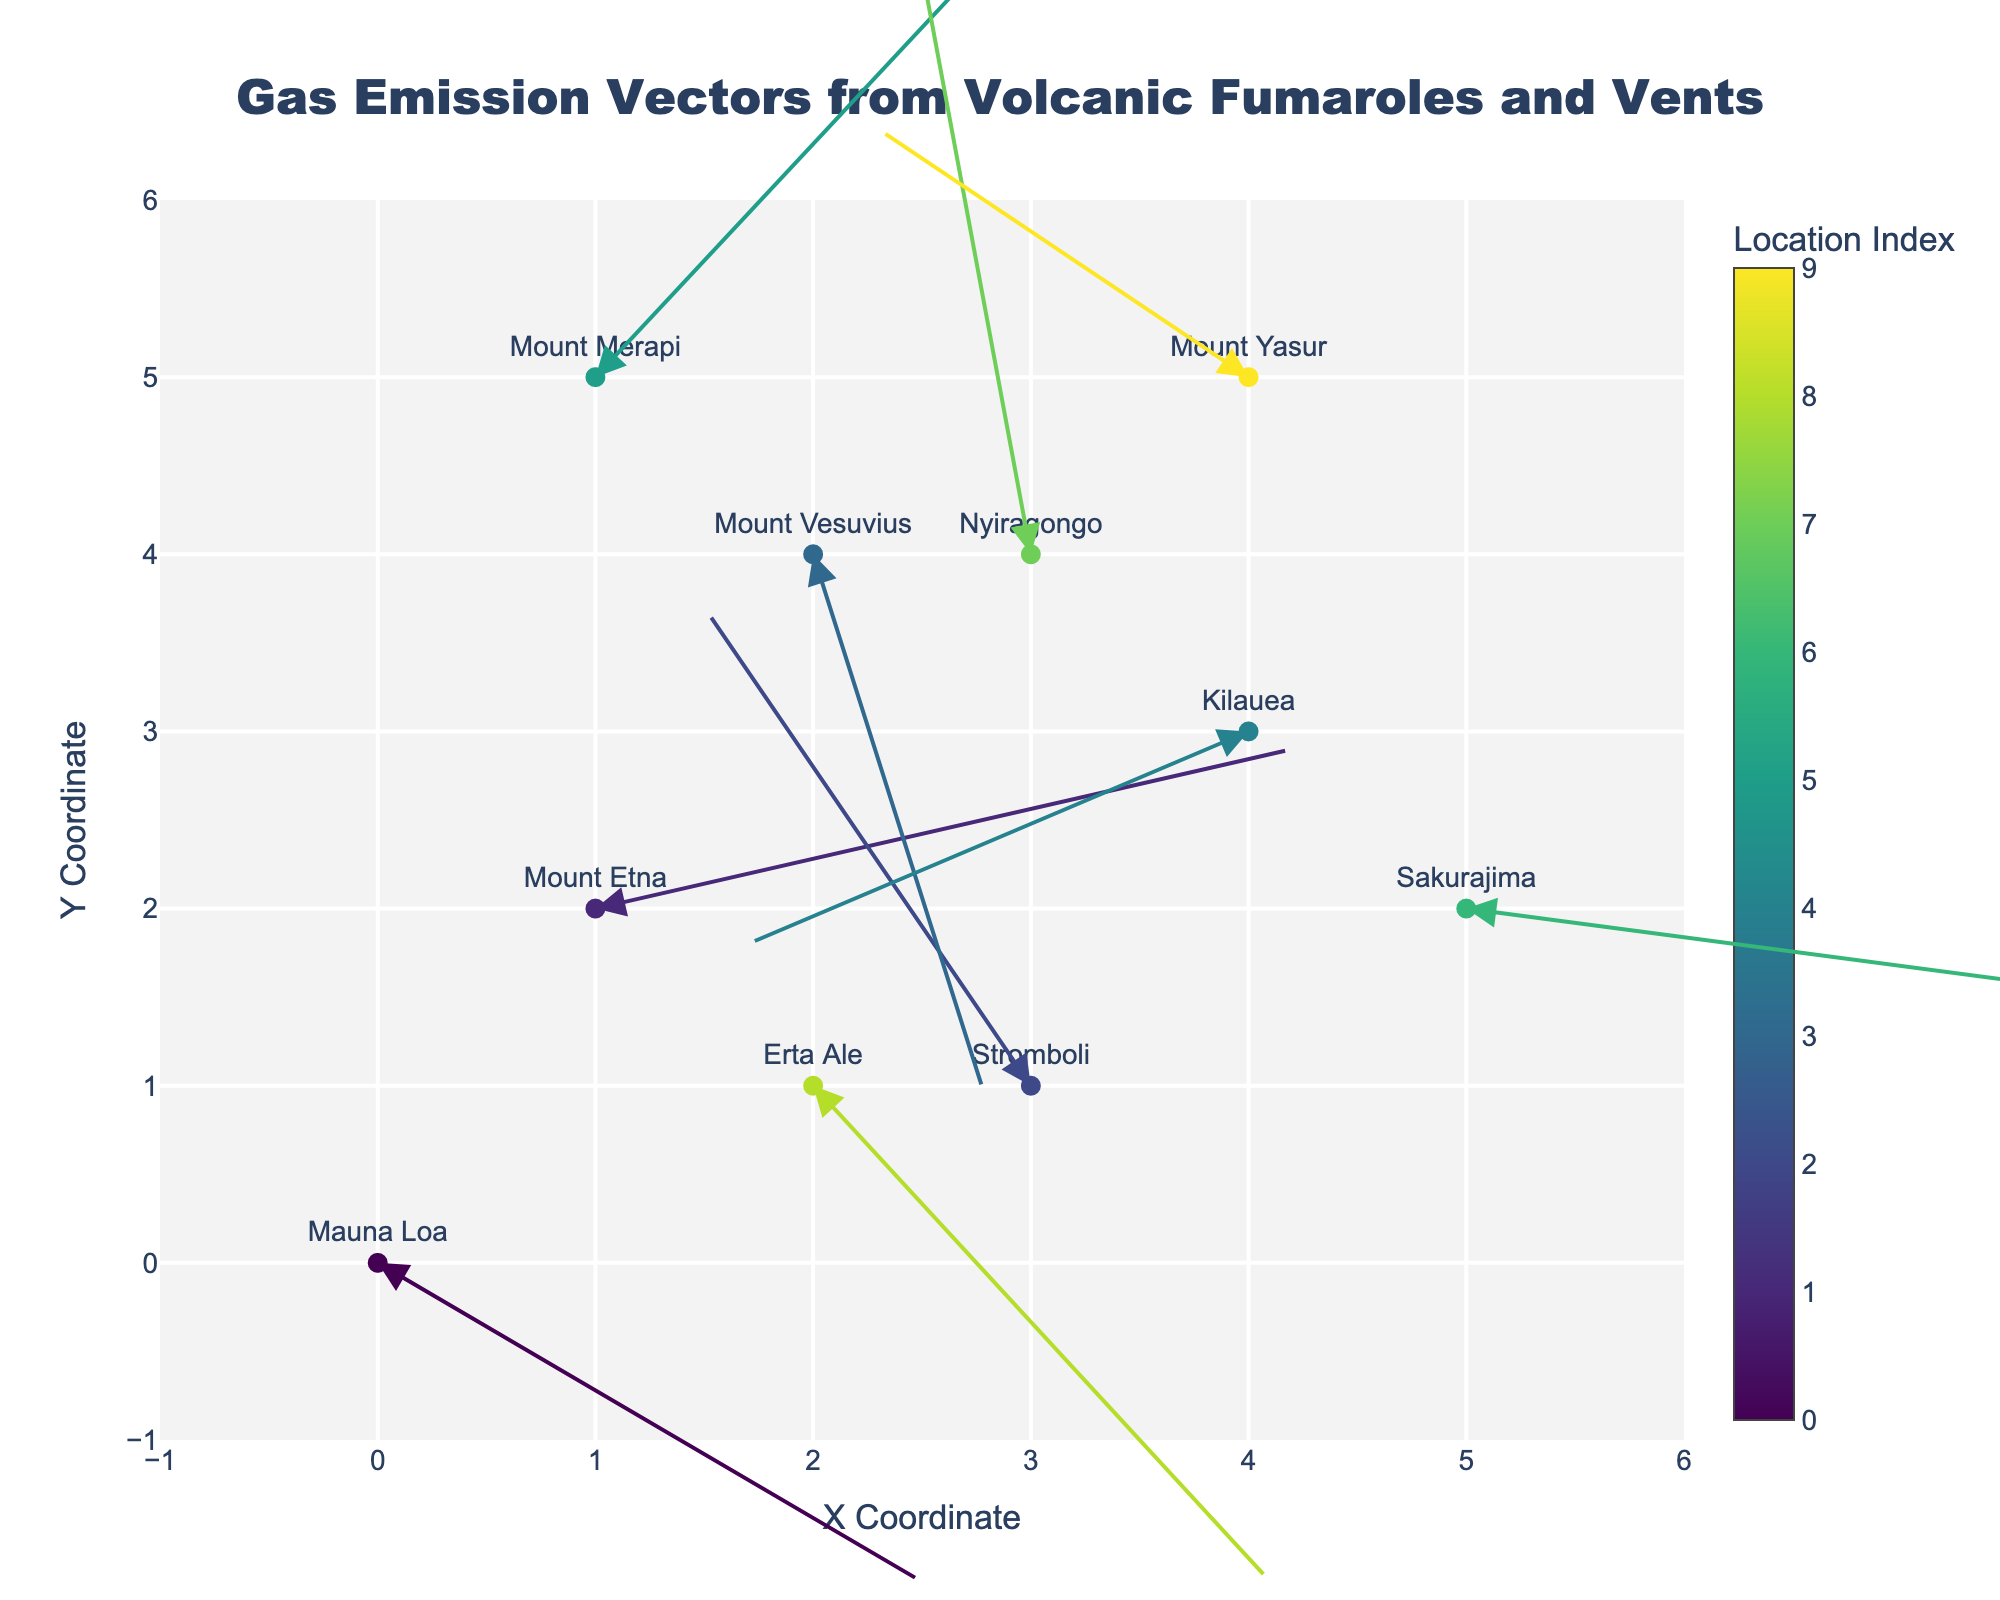What's the title of the figure? The title is displayed at the top center of the figure in large font, observing it will give the answer.
Answer: Gas Emission Vectors from Volcanic Fumaroles and Vents How many volcano locations are represented in the quiver plot? Counting the distinct text labels associated with each point in the plot provides the number of locations depicted.
Answer: 10 What is the x-coordinate and y-coordinate range in the figure? The x-axis and y-axis have their ranges defined within the plot. Observing the tick marks and axis limits yields the coordinate range.
Answer: -1 to 6 Which location has the longest arrow vector? By visually inspecting the length of each arrow, we can identify the longest one, represented by both magnitude and direction. Sakurajima has the longest arrow vector (3.7, -0.6).
Answer: Sakurajima Are there any locations where the arrows point predominantly downwards? Observing the direction of arrows from each labeled point, particularly the ones having a significant negative y-component, reveals the answer. Both Mauna Loa and Erta Ale have arrows pointing predominantly downwards.
Answer: Yes, Mauna Loa and Erta Ale Which arrow points directly to the top right (positive x and y direction) and from which location? Inspect the arrows that have both positive u and v components to find those pointing towards the top right. Mount Etna (3.2, 0.9).
Answer: Mount Etna What is the x-coordinate of the location Kilauea? Identify the text label "Kilauea" and read off its corresponding x-coordinate from the plot.
Answer: 4 Comparing the vectors from Mount Vesuvius and Mount Merapi, which location has a stronger downward component? Compare the v-components of both vectors; identify the one with a more negative value to indicate a stronger downward component. Mount Vesuvius has the stronger downward component with a v = -3.1.
Answer: Mount Vesuvius What is the average length of the vectors for all the locations? Calculate the length of each vector using the formula sqrt(u^2 + v^2) and then find the average of these lengths.
Answer: Approximately 2.71 Which locations have vectors pointing mostly to the left (negative x direction)? Check the u-components of the arrows and identify the arrows where u is negative, indicating a direction towards the left.
Answer: Stromboli and Kilauea 